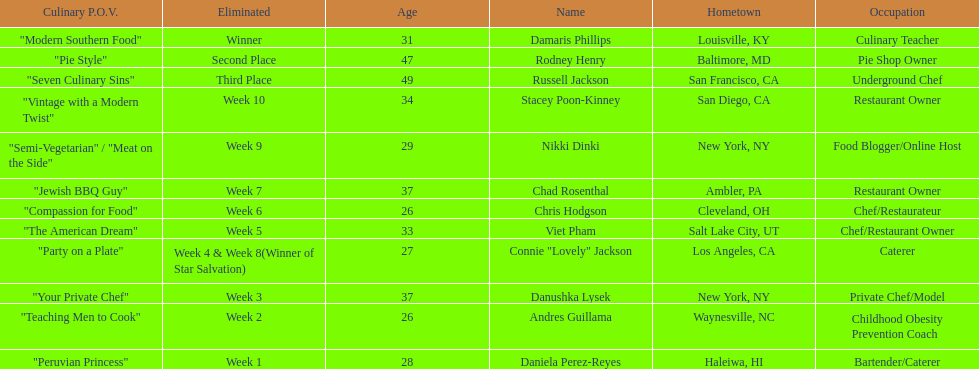How many competitors were under the age of 30? 5. 